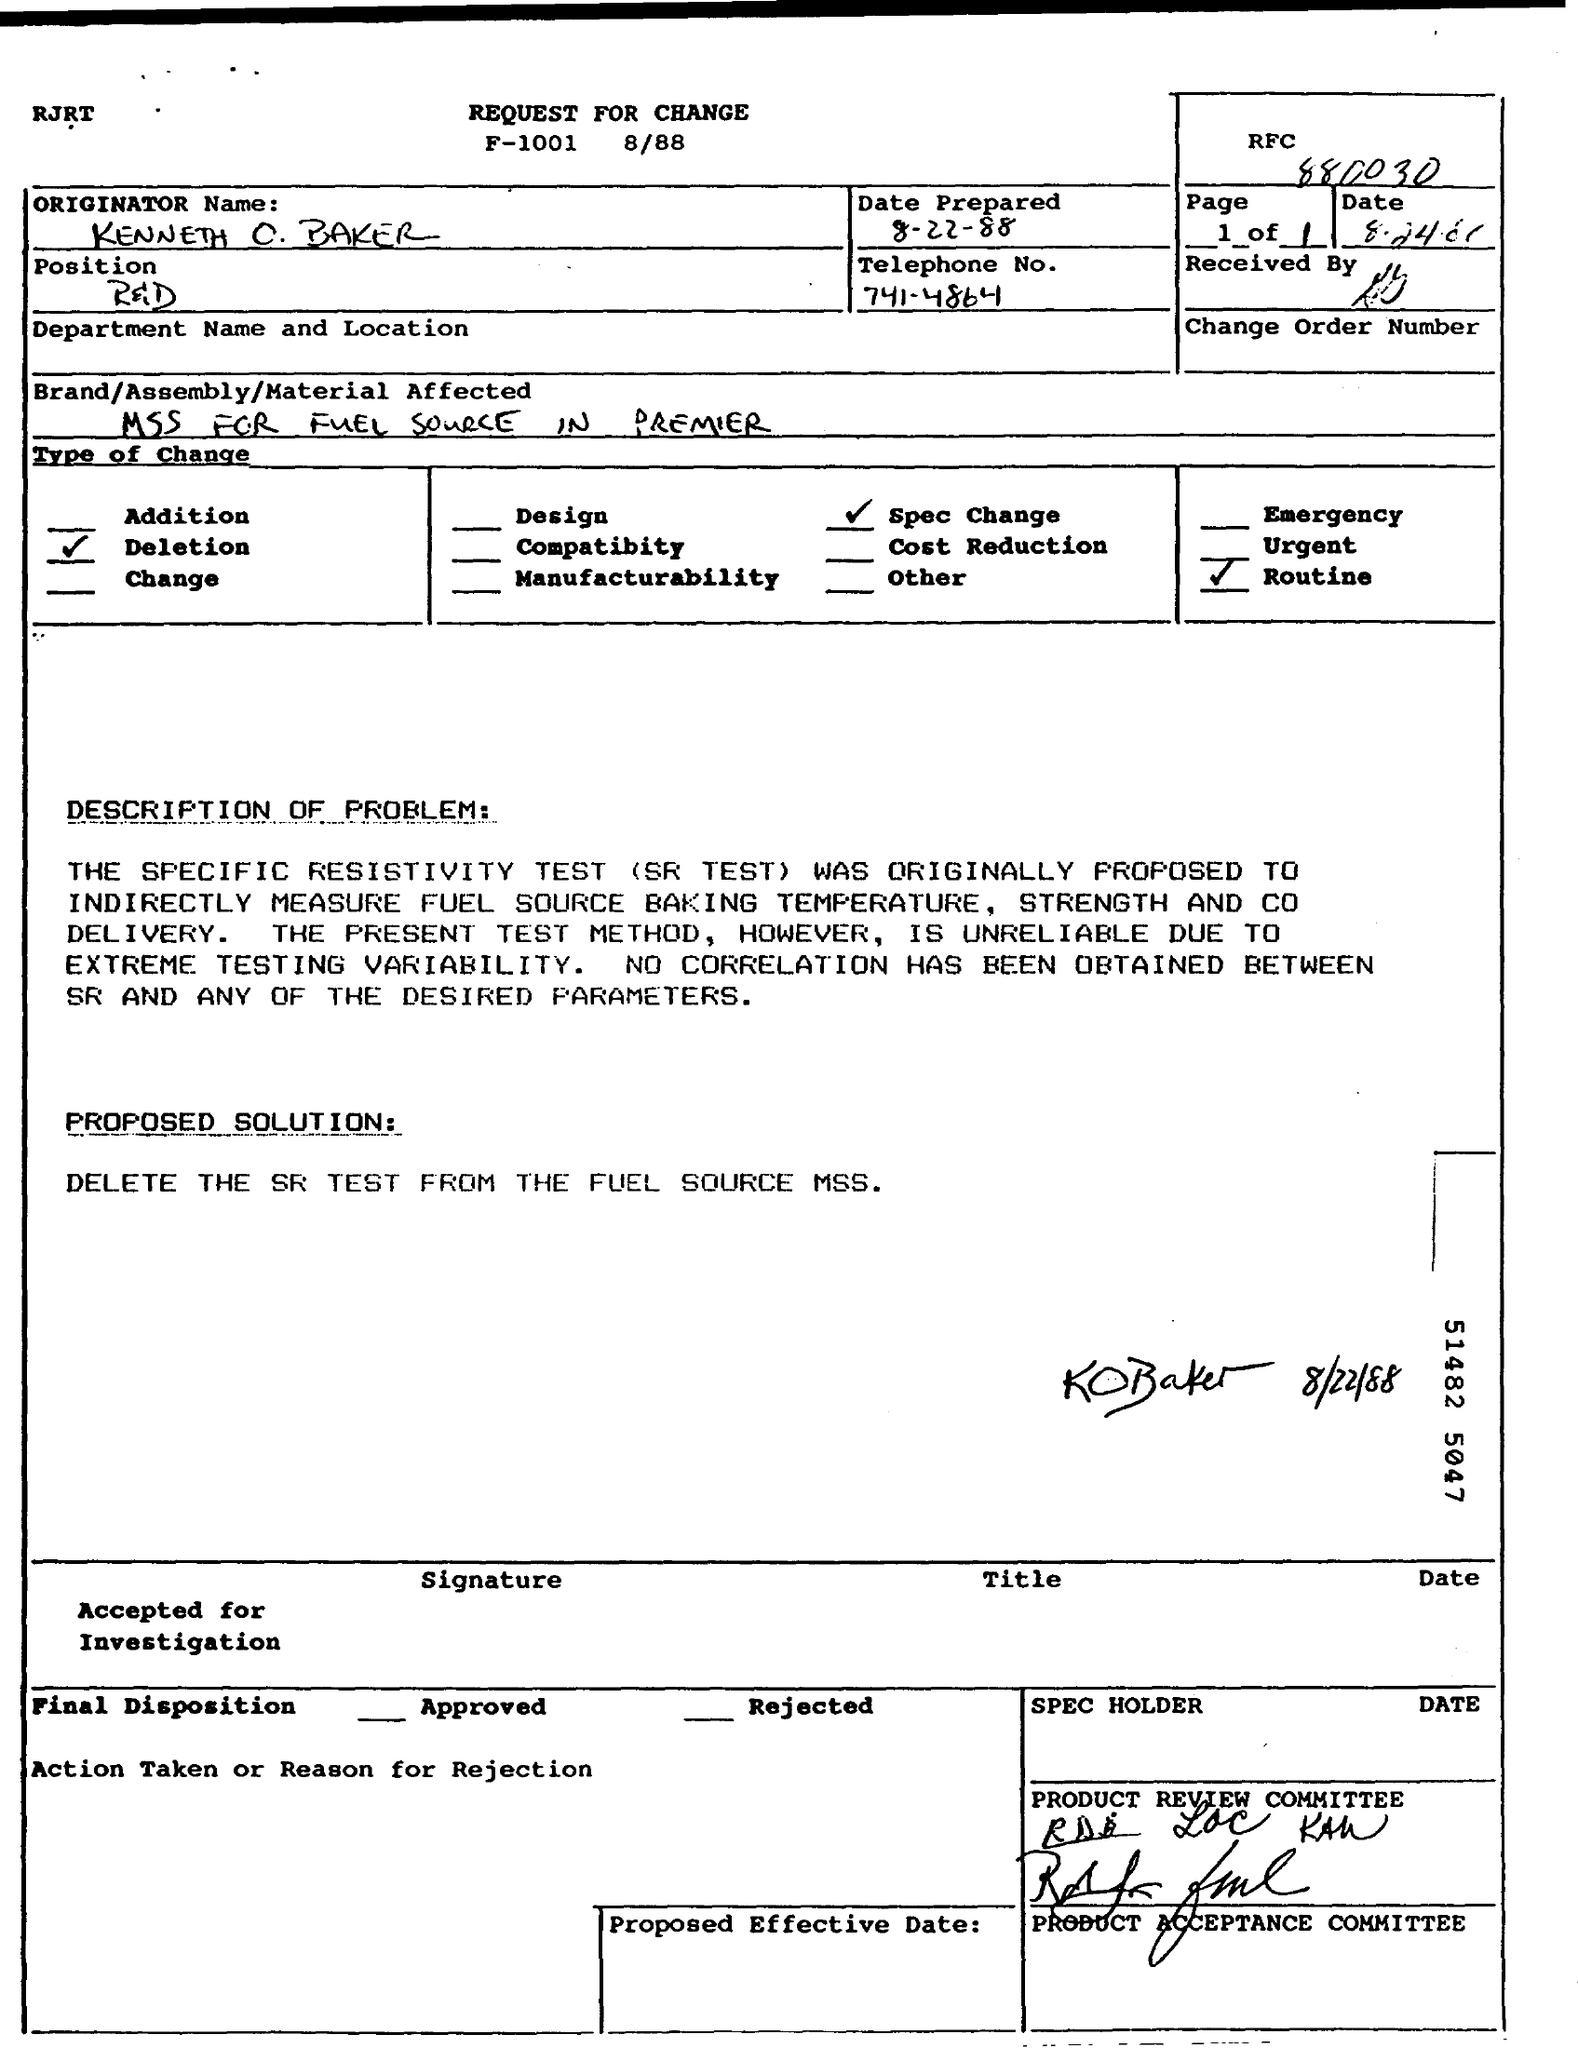List a handful of essential elements in this visual. The document provides the name of the Originator as Kenneth O. Baker. The date was prepared as indicated in the document, which is 8-22-88. What is the impact of the brand, assembly, and material used on the fuel source in the premier document? The solution proposed in the document is to remove SR testing from the fuel source MSS. The telephone number mentioned in this document is 741-4864. 